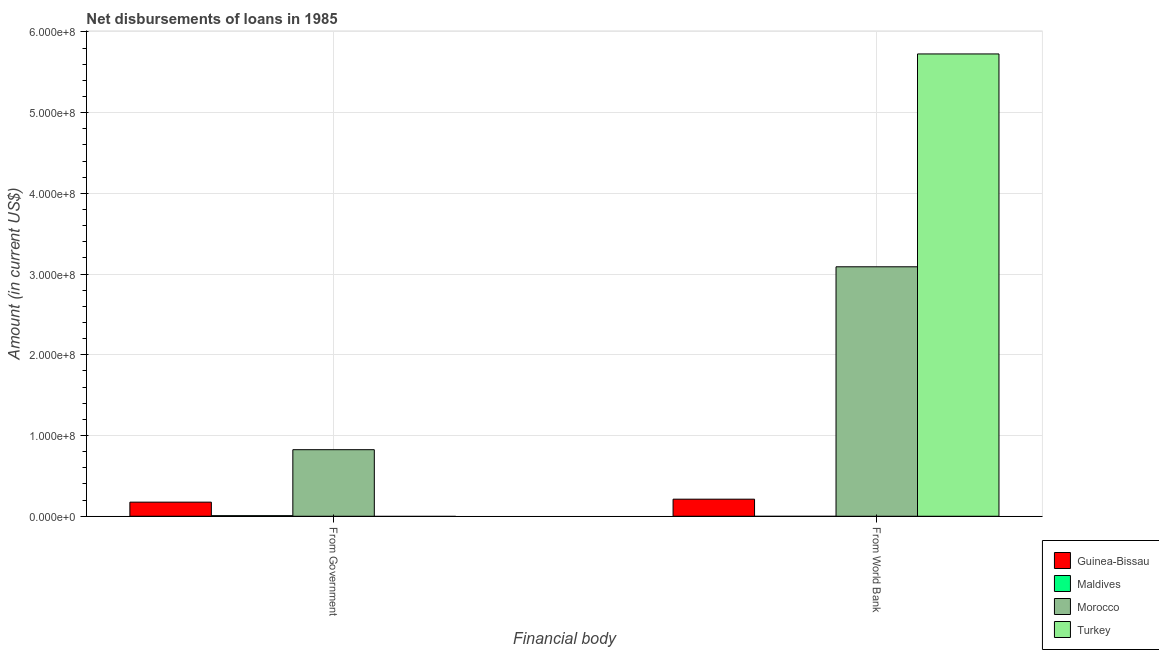How many different coloured bars are there?
Offer a terse response. 4. Are the number of bars per tick equal to the number of legend labels?
Give a very brief answer. No. Are the number of bars on each tick of the X-axis equal?
Give a very brief answer. Yes. How many bars are there on the 2nd tick from the left?
Your answer should be compact. 3. What is the label of the 2nd group of bars from the left?
Your response must be concise. From World Bank. What is the net disbursements of loan from world bank in Morocco?
Offer a terse response. 3.09e+08. Across all countries, what is the maximum net disbursements of loan from world bank?
Give a very brief answer. 5.73e+08. Across all countries, what is the minimum net disbursements of loan from world bank?
Offer a terse response. 0. What is the total net disbursements of loan from world bank in the graph?
Offer a terse response. 9.03e+08. What is the difference between the net disbursements of loan from government in Morocco and that in Maldives?
Provide a short and direct response. 8.17e+07. What is the difference between the net disbursements of loan from world bank in Guinea-Bissau and the net disbursements of loan from government in Maldives?
Your answer should be very brief. 2.04e+07. What is the average net disbursements of loan from world bank per country?
Provide a succinct answer. 2.26e+08. What is the difference between the net disbursements of loan from world bank and net disbursements of loan from government in Guinea-Bissau?
Keep it short and to the point. 3.66e+06. What is the ratio of the net disbursements of loan from government in Guinea-Bissau to that in Maldives?
Make the answer very short. 24.79. In how many countries, is the net disbursements of loan from government greater than the average net disbursements of loan from government taken over all countries?
Offer a terse response. 1. How many bars are there?
Your answer should be compact. 6. How many countries are there in the graph?
Give a very brief answer. 4. What is the difference between two consecutive major ticks on the Y-axis?
Ensure brevity in your answer.  1.00e+08. Does the graph contain grids?
Make the answer very short. Yes. Where does the legend appear in the graph?
Keep it short and to the point. Bottom right. What is the title of the graph?
Make the answer very short. Net disbursements of loans in 1985. What is the label or title of the X-axis?
Keep it short and to the point. Financial body. What is the Amount (in current US$) in Guinea-Bissau in From Government?
Ensure brevity in your answer.  1.75e+07. What is the Amount (in current US$) of Maldives in From Government?
Keep it short and to the point. 7.05e+05. What is the Amount (in current US$) in Morocco in From Government?
Provide a succinct answer. 8.24e+07. What is the Amount (in current US$) of Guinea-Bissau in From World Bank?
Make the answer very short. 2.11e+07. What is the Amount (in current US$) of Maldives in From World Bank?
Your answer should be very brief. 0. What is the Amount (in current US$) of Morocco in From World Bank?
Offer a very short reply. 3.09e+08. What is the Amount (in current US$) in Turkey in From World Bank?
Provide a short and direct response. 5.73e+08. Across all Financial body, what is the maximum Amount (in current US$) in Guinea-Bissau?
Make the answer very short. 2.11e+07. Across all Financial body, what is the maximum Amount (in current US$) of Maldives?
Your answer should be very brief. 7.05e+05. Across all Financial body, what is the maximum Amount (in current US$) in Morocco?
Your answer should be very brief. 3.09e+08. Across all Financial body, what is the maximum Amount (in current US$) in Turkey?
Provide a short and direct response. 5.73e+08. Across all Financial body, what is the minimum Amount (in current US$) in Guinea-Bissau?
Your answer should be very brief. 1.75e+07. Across all Financial body, what is the minimum Amount (in current US$) in Maldives?
Ensure brevity in your answer.  0. Across all Financial body, what is the minimum Amount (in current US$) in Morocco?
Give a very brief answer. 8.24e+07. What is the total Amount (in current US$) in Guinea-Bissau in the graph?
Make the answer very short. 3.86e+07. What is the total Amount (in current US$) in Maldives in the graph?
Your answer should be compact. 7.05e+05. What is the total Amount (in current US$) in Morocco in the graph?
Keep it short and to the point. 3.91e+08. What is the total Amount (in current US$) in Turkey in the graph?
Give a very brief answer. 5.73e+08. What is the difference between the Amount (in current US$) in Guinea-Bissau in From Government and that in From World Bank?
Provide a succinct answer. -3.66e+06. What is the difference between the Amount (in current US$) in Morocco in From Government and that in From World Bank?
Your response must be concise. -2.27e+08. What is the difference between the Amount (in current US$) of Guinea-Bissau in From Government and the Amount (in current US$) of Morocco in From World Bank?
Keep it short and to the point. -2.92e+08. What is the difference between the Amount (in current US$) of Guinea-Bissau in From Government and the Amount (in current US$) of Turkey in From World Bank?
Provide a short and direct response. -5.55e+08. What is the difference between the Amount (in current US$) of Maldives in From Government and the Amount (in current US$) of Morocco in From World Bank?
Provide a short and direct response. -3.08e+08. What is the difference between the Amount (in current US$) of Maldives in From Government and the Amount (in current US$) of Turkey in From World Bank?
Offer a very short reply. -5.72e+08. What is the difference between the Amount (in current US$) of Morocco in From Government and the Amount (in current US$) of Turkey in From World Bank?
Give a very brief answer. -4.90e+08. What is the average Amount (in current US$) of Guinea-Bissau per Financial body?
Offer a terse response. 1.93e+07. What is the average Amount (in current US$) in Maldives per Financial body?
Give a very brief answer. 3.52e+05. What is the average Amount (in current US$) in Morocco per Financial body?
Your response must be concise. 1.96e+08. What is the average Amount (in current US$) of Turkey per Financial body?
Your answer should be very brief. 2.86e+08. What is the difference between the Amount (in current US$) in Guinea-Bissau and Amount (in current US$) in Maldives in From Government?
Give a very brief answer. 1.68e+07. What is the difference between the Amount (in current US$) of Guinea-Bissau and Amount (in current US$) of Morocco in From Government?
Provide a succinct answer. -6.50e+07. What is the difference between the Amount (in current US$) of Maldives and Amount (in current US$) of Morocco in From Government?
Ensure brevity in your answer.  -8.17e+07. What is the difference between the Amount (in current US$) in Guinea-Bissau and Amount (in current US$) in Morocco in From World Bank?
Keep it short and to the point. -2.88e+08. What is the difference between the Amount (in current US$) of Guinea-Bissau and Amount (in current US$) of Turkey in From World Bank?
Keep it short and to the point. -5.52e+08. What is the difference between the Amount (in current US$) in Morocco and Amount (in current US$) in Turkey in From World Bank?
Your response must be concise. -2.64e+08. What is the ratio of the Amount (in current US$) of Guinea-Bissau in From Government to that in From World Bank?
Keep it short and to the point. 0.83. What is the ratio of the Amount (in current US$) in Morocco in From Government to that in From World Bank?
Ensure brevity in your answer.  0.27. What is the difference between the highest and the second highest Amount (in current US$) of Guinea-Bissau?
Your answer should be compact. 3.66e+06. What is the difference between the highest and the second highest Amount (in current US$) of Morocco?
Your answer should be compact. 2.27e+08. What is the difference between the highest and the lowest Amount (in current US$) of Guinea-Bissau?
Provide a short and direct response. 3.66e+06. What is the difference between the highest and the lowest Amount (in current US$) in Maldives?
Offer a terse response. 7.05e+05. What is the difference between the highest and the lowest Amount (in current US$) in Morocco?
Your answer should be very brief. 2.27e+08. What is the difference between the highest and the lowest Amount (in current US$) in Turkey?
Make the answer very short. 5.73e+08. 